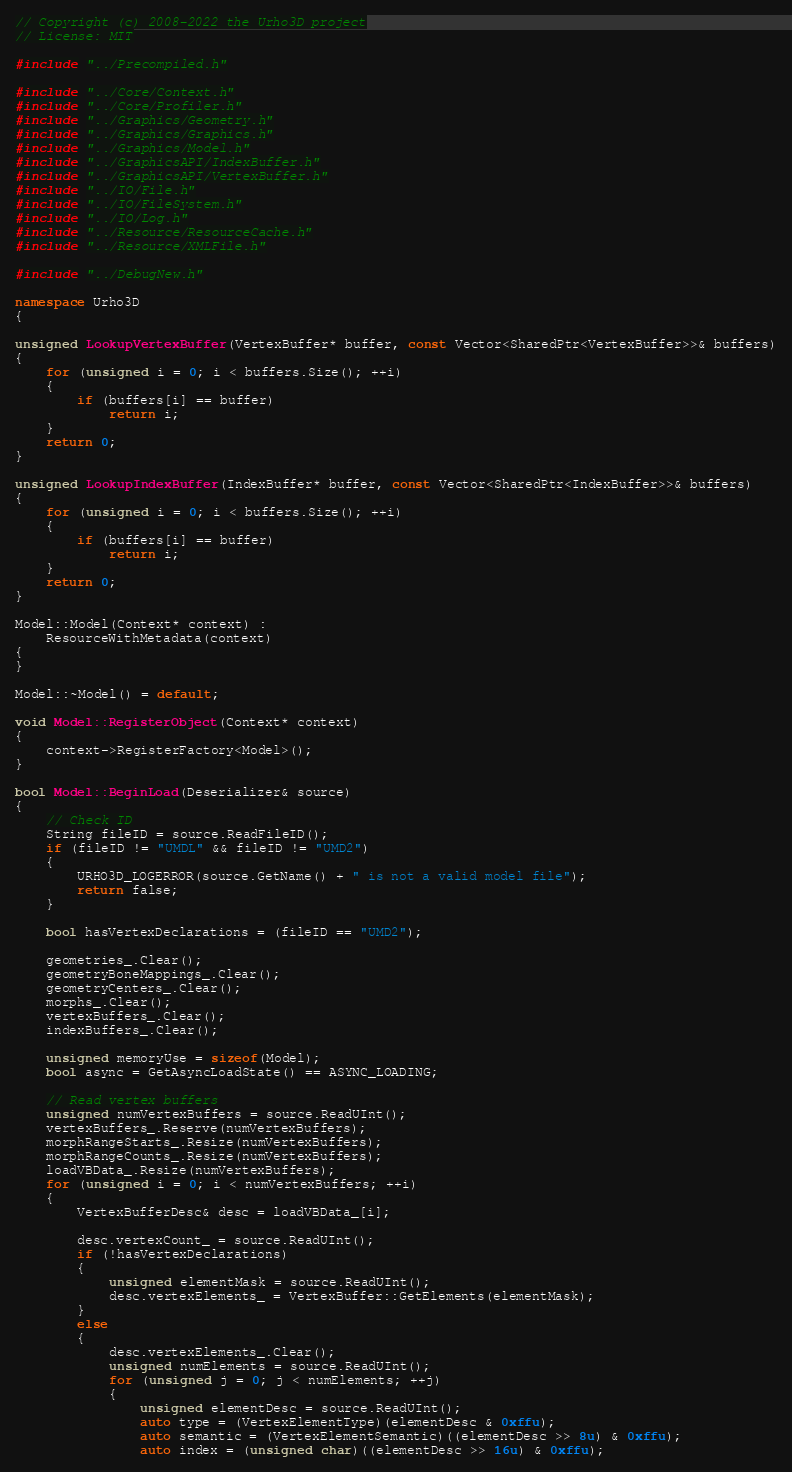<code> <loc_0><loc_0><loc_500><loc_500><_C++_>// Copyright (c) 2008-2022 the Urho3D project
// License: MIT

#include "../Precompiled.h"

#include "../Core/Context.h"
#include "../Core/Profiler.h"
#include "../Graphics/Geometry.h"
#include "../Graphics/Graphics.h"
#include "../Graphics/Model.h"
#include "../GraphicsAPI/IndexBuffer.h"
#include "../GraphicsAPI/VertexBuffer.h"
#include "../IO/File.h"
#include "../IO/FileSystem.h"
#include "../IO/Log.h"
#include "../Resource/ResourceCache.h"
#include "../Resource/XMLFile.h"

#include "../DebugNew.h"

namespace Urho3D
{

unsigned LookupVertexBuffer(VertexBuffer* buffer, const Vector<SharedPtr<VertexBuffer>>& buffers)
{
    for (unsigned i = 0; i < buffers.Size(); ++i)
    {
        if (buffers[i] == buffer)
            return i;
    }
    return 0;
}

unsigned LookupIndexBuffer(IndexBuffer* buffer, const Vector<SharedPtr<IndexBuffer>>& buffers)
{
    for (unsigned i = 0; i < buffers.Size(); ++i)
    {
        if (buffers[i] == buffer)
            return i;
    }
    return 0;
}

Model::Model(Context* context) :
    ResourceWithMetadata(context)
{
}

Model::~Model() = default;

void Model::RegisterObject(Context* context)
{
    context->RegisterFactory<Model>();
}

bool Model::BeginLoad(Deserializer& source)
{
    // Check ID
    String fileID = source.ReadFileID();
    if (fileID != "UMDL" && fileID != "UMD2")
    {
        URHO3D_LOGERROR(source.GetName() + " is not a valid model file");
        return false;
    }

    bool hasVertexDeclarations = (fileID == "UMD2");

    geometries_.Clear();
    geometryBoneMappings_.Clear();
    geometryCenters_.Clear();
    morphs_.Clear();
    vertexBuffers_.Clear();
    indexBuffers_.Clear();

    unsigned memoryUse = sizeof(Model);
    bool async = GetAsyncLoadState() == ASYNC_LOADING;

    // Read vertex buffers
    unsigned numVertexBuffers = source.ReadUInt();
    vertexBuffers_.Reserve(numVertexBuffers);
    morphRangeStarts_.Resize(numVertexBuffers);
    morphRangeCounts_.Resize(numVertexBuffers);
    loadVBData_.Resize(numVertexBuffers);
    for (unsigned i = 0; i < numVertexBuffers; ++i)
    {
        VertexBufferDesc& desc = loadVBData_[i];

        desc.vertexCount_ = source.ReadUInt();
        if (!hasVertexDeclarations)
        {
            unsigned elementMask = source.ReadUInt();
            desc.vertexElements_ = VertexBuffer::GetElements(elementMask);
        }
        else
        {
            desc.vertexElements_.Clear();
            unsigned numElements = source.ReadUInt();
            for (unsigned j = 0; j < numElements; ++j)
            {
                unsigned elementDesc = source.ReadUInt();
                auto type = (VertexElementType)(elementDesc & 0xffu);
                auto semantic = (VertexElementSemantic)((elementDesc >> 8u) & 0xffu);
                auto index = (unsigned char)((elementDesc >> 16u) & 0xffu);</code> 